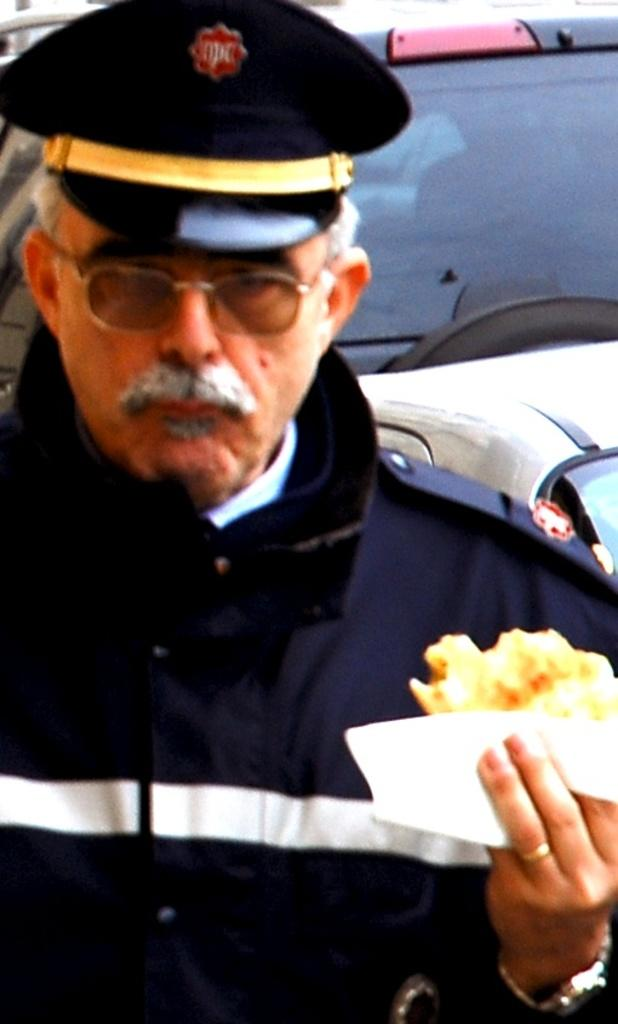What type of person can be seen in the image? There is a policeman in the image. What is the policeman holding in his hand? The policeman is holding a food item in his hand. What can be seen in the image that might be used for transportation? There is a vehicle with a windshield visible in the image. Where is the basin located in the image? There is no basin present in the image. How many children are visible in the image? There are no children visible in the image. 